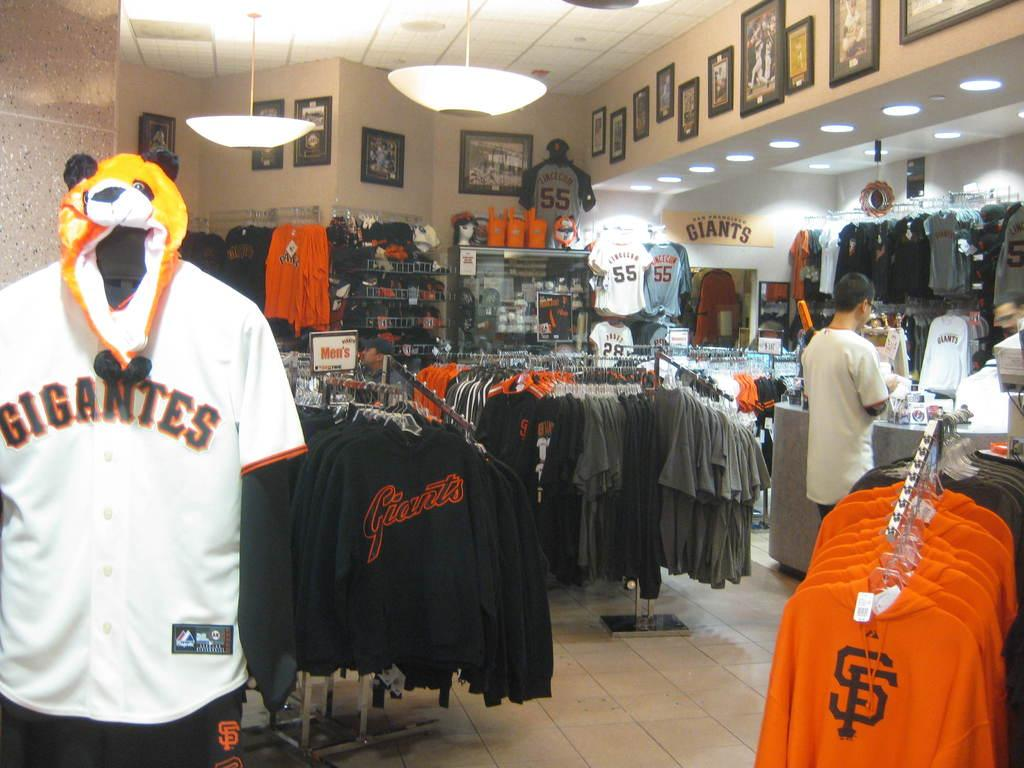<image>
Present a compact description of the photo's key features. a store specifically with 'giants' merchandise in i 